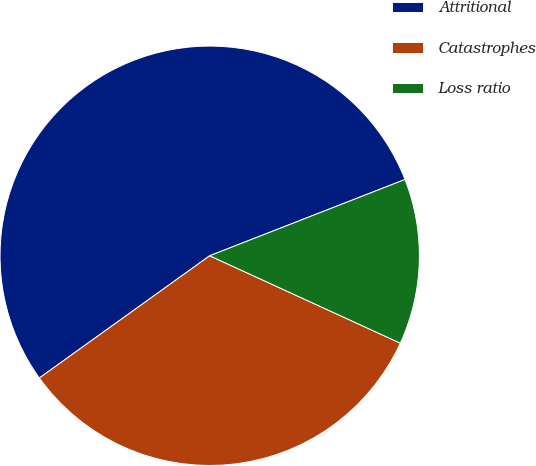Convert chart to OTSL. <chart><loc_0><loc_0><loc_500><loc_500><pie_chart><fcel>Attritional<fcel>Catastrophes<fcel>Loss ratio<nl><fcel>53.98%<fcel>33.25%<fcel>12.77%<nl></chart> 